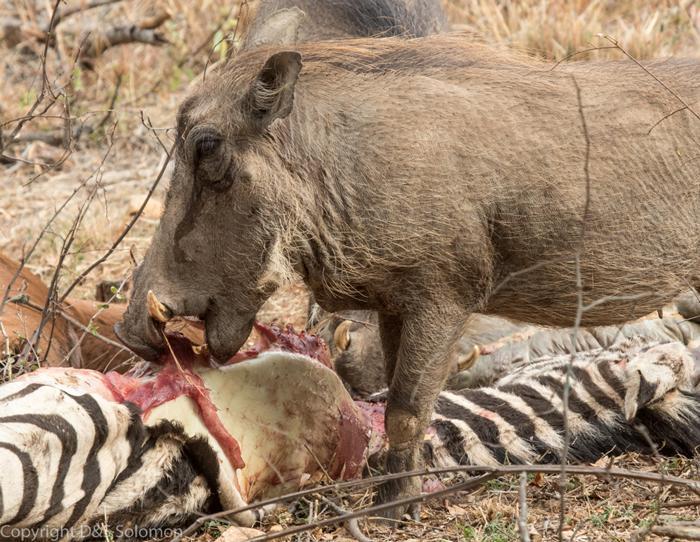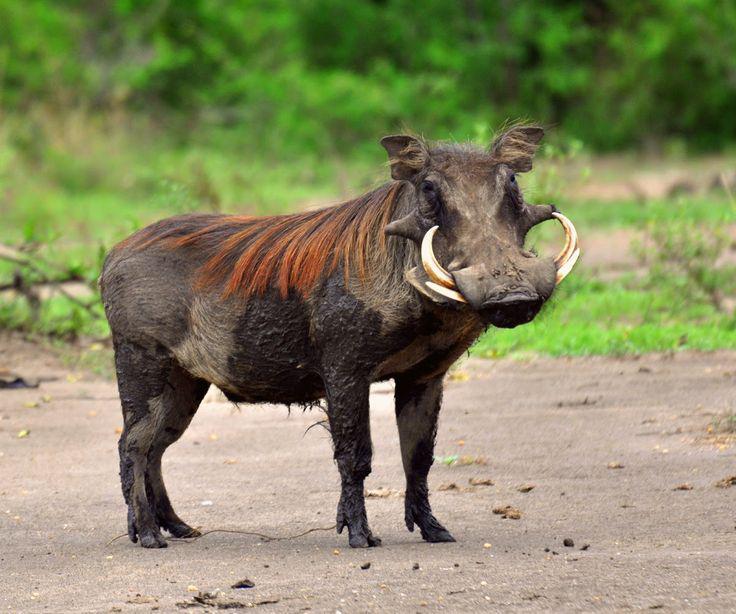The first image is the image on the left, the second image is the image on the right. Assess this claim about the two images: "the hog on the right image is facing left.". Correct or not? Answer yes or no. No. 